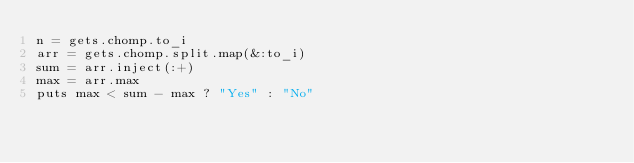Convert code to text. <code><loc_0><loc_0><loc_500><loc_500><_Ruby_>n = gets.chomp.to_i
arr = gets.chomp.split.map(&:to_i)
sum = arr.inject(:+)
max = arr.max
puts max < sum - max ? "Yes" : "No"</code> 